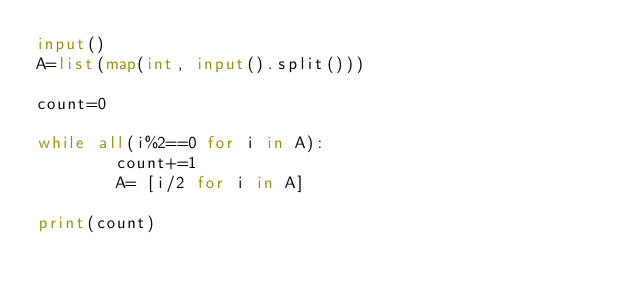<code> <loc_0><loc_0><loc_500><loc_500><_Python_>input()
A=list(map(int, input().split()))

count=0

while all(i%2==0 for i in A):
        count+=1
        A= [i/2 for i in A]

print(count)</code> 